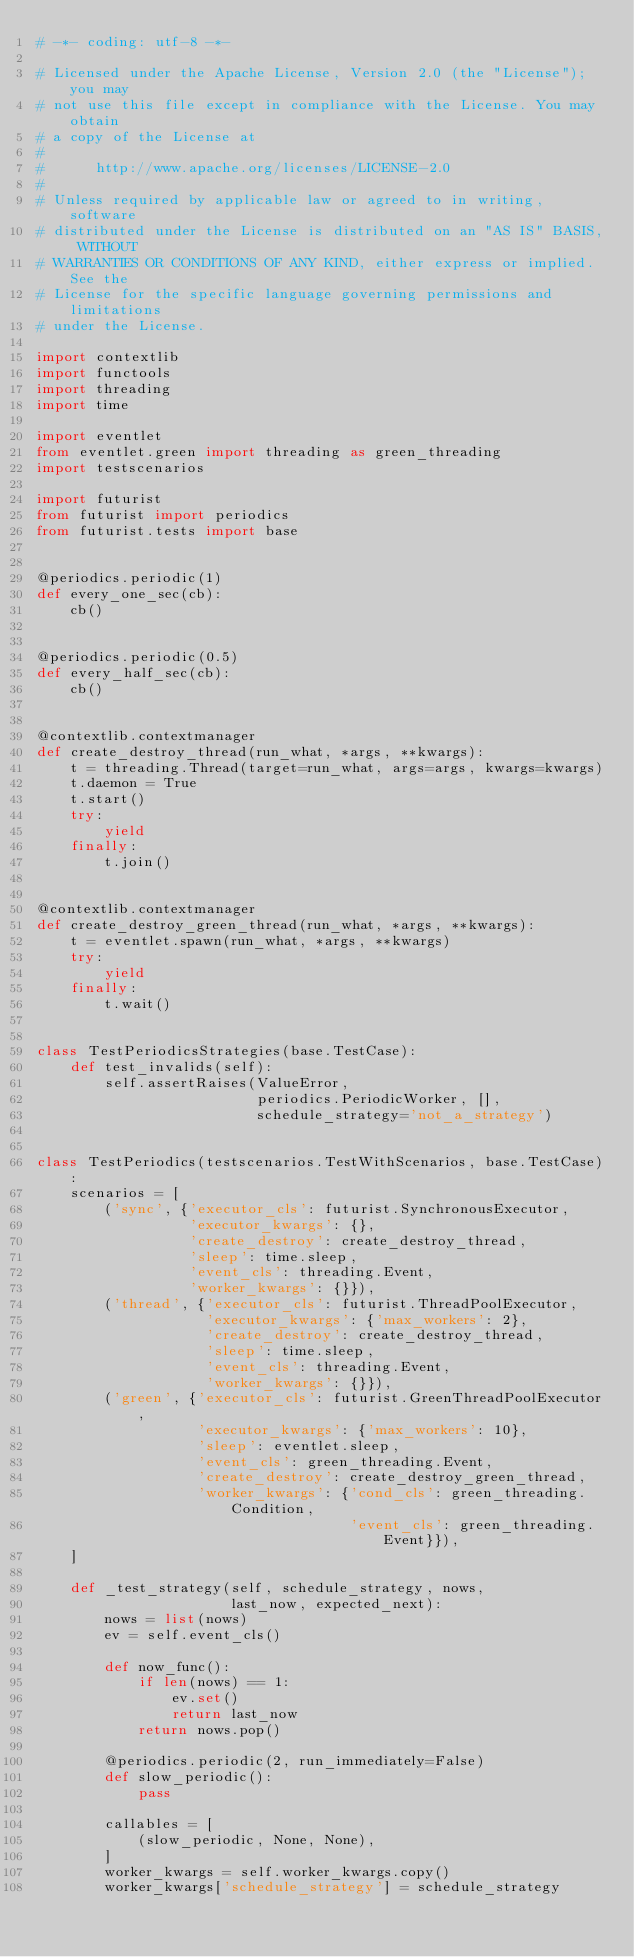Convert code to text. <code><loc_0><loc_0><loc_500><loc_500><_Python_># -*- coding: utf-8 -*-

# Licensed under the Apache License, Version 2.0 (the "License"); you may
# not use this file except in compliance with the License. You may obtain
# a copy of the License at
#
#      http://www.apache.org/licenses/LICENSE-2.0
#
# Unless required by applicable law or agreed to in writing, software
# distributed under the License is distributed on an "AS IS" BASIS, WITHOUT
# WARRANTIES OR CONDITIONS OF ANY KIND, either express or implied. See the
# License for the specific language governing permissions and limitations
# under the License.

import contextlib
import functools
import threading
import time

import eventlet
from eventlet.green import threading as green_threading
import testscenarios

import futurist
from futurist import periodics
from futurist.tests import base


@periodics.periodic(1)
def every_one_sec(cb):
    cb()


@periodics.periodic(0.5)
def every_half_sec(cb):
    cb()


@contextlib.contextmanager
def create_destroy_thread(run_what, *args, **kwargs):
    t = threading.Thread(target=run_what, args=args, kwargs=kwargs)
    t.daemon = True
    t.start()
    try:
        yield
    finally:
        t.join()


@contextlib.contextmanager
def create_destroy_green_thread(run_what, *args, **kwargs):
    t = eventlet.spawn(run_what, *args, **kwargs)
    try:
        yield
    finally:
        t.wait()


class TestPeriodicsStrategies(base.TestCase):
    def test_invalids(self):
        self.assertRaises(ValueError,
                          periodics.PeriodicWorker, [],
                          schedule_strategy='not_a_strategy')


class TestPeriodics(testscenarios.TestWithScenarios, base.TestCase):
    scenarios = [
        ('sync', {'executor_cls': futurist.SynchronousExecutor,
                  'executor_kwargs': {},
                  'create_destroy': create_destroy_thread,
                  'sleep': time.sleep,
                  'event_cls': threading.Event,
                  'worker_kwargs': {}}),
        ('thread', {'executor_cls': futurist.ThreadPoolExecutor,
                    'executor_kwargs': {'max_workers': 2},
                    'create_destroy': create_destroy_thread,
                    'sleep': time.sleep,
                    'event_cls': threading.Event,
                    'worker_kwargs': {}}),
        ('green', {'executor_cls': futurist.GreenThreadPoolExecutor,
                   'executor_kwargs': {'max_workers': 10},
                   'sleep': eventlet.sleep,
                   'event_cls': green_threading.Event,
                   'create_destroy': create_destroy_green_thread,
                   'worker_kwargs': {'cond_cls': green_threading.Condition,
                                     'event_cls': green_threading.Event}}),
    ]

    def _test_strategy(self, schedule_strategy, nows,
                       last_now, expected_next):
        nows = list(nows)
        ev = self.event_cls()

        def now_func():
            if len(nows) == 1:
                ev.set()
                return last_now
            return nows.pop()

        @periodics.periodic(2, run_immediately=False)
        def slow_periodic():
            pass

        callables = [
            (slow_periodic, None, None),
        ]
        worker_kwargs = self.worker_kwargs.copy()
        worker_kwargs['schedule_strategy'] = schedule_strategy</code> 